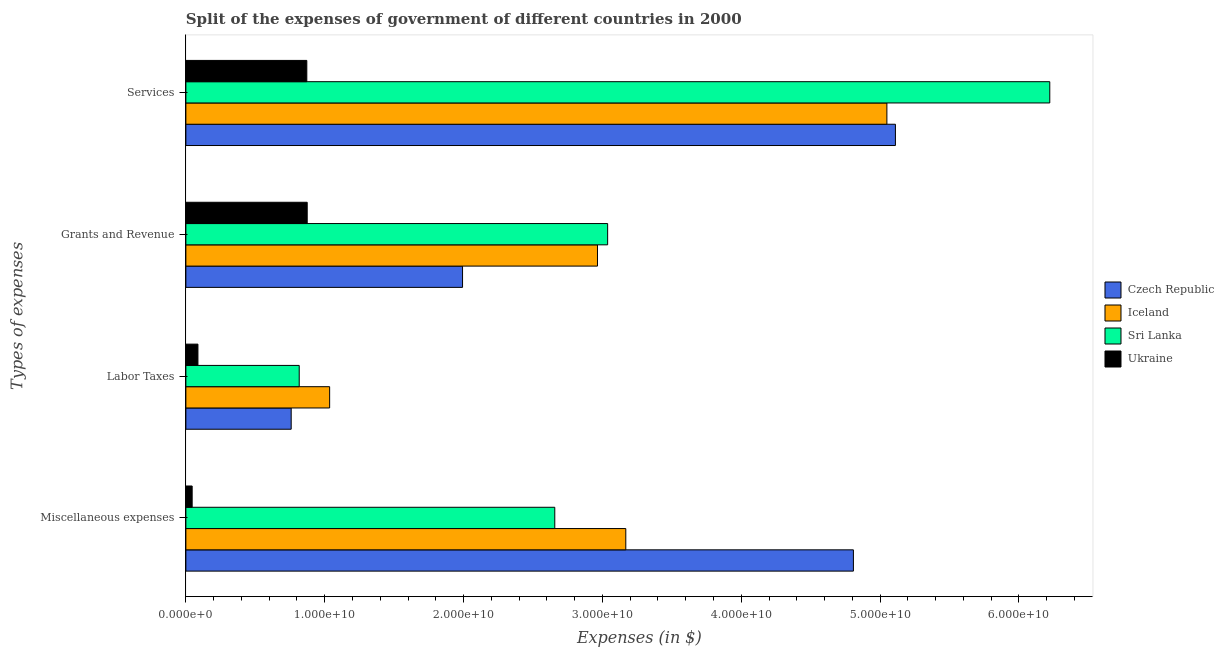How many groups of bars are there?
Provide a short and direct response. 4. Are the number of bars per tick equal to the number of legend labels?
Give a very brief answer. Yes. What is the label of the 2nd group of bars from the top?
Keep it short and to the point. Grants and Revenue. What is the amount spent on labor taxes in Ukraine?
Make the answer very short. 8.69e+08. Across all countries, what is the maximum amount spent on miscellaneous expenses?
Provide a short and direct response. 4.81e+1. Across all countries, what is the minimum amount spent on miscellaneous expenses?
Your response must be concise. 4.53e+08. In which country was the amount spent on miscellaneous expenses maximum?
Keep it short and to the point. Czech Republic. In which country was the amount spent on miscellaneous expenses minimum?
Keep it short and to the point. Ukraine. What is the total amount spent on services in the graph?
Your answer should be compact. 1.73e+11. What is the difference between the amount spent on grants and revenue in Czech Republic and that in Sri Lanka?
Ensure brevity in your answer.  -1.04e+1. What is the difference between the amount spent on miscellaneous expenses in Iceland and the amount spent on grants and revenue in Sri Lanka?
Keep it short and to the point. 1.31e+09. What is the average amount spent on grants and revenue per country?
Your answer should be very brief. 2.22e+1. What is the difference between the amount spent on services and amount spent on labor taxes in Iceland?
Offer a terse response. 4.01e+1. In how many countries, is the amount spent on services greater than 52000000000 $?
Keep it short and to the point. 1. What is the ratio of the amount spent on services in Iceland to that in Sri Lanka?
Offer a terse response. 0.81. Is the difference between the amount spent on labor taxes in Iceland and Czech Republic greater than the difference between the amount spent on services in Iceland and Czech Republic?
Provide a succinct answer. Yes. What is the difference between the highest and the second highest amount spent on labor taxes?
Make the answer very short. 2.19e+09. What is the difference between the highest and the lowest amount spent on services?
Your answer should be very brief. 5.35e+1. In how many countries, is the amount spent on grants and revenue greater than the average amount spent on grants and revenue taken over all countries?
Ensure brevity in your answer.  2. Is it the case that in every country, the sum of the amount spent on miscellaneous expenses and amount spent on grants and revenue is greater than the sum of amount spent on labor taxes and amount spent on services?
Keep it short and to the point. No. What does the 4th bar from the top in Services represents?
Provide a short and direct response. Czech Republic. What does the 1st bar from the bottom in Labor Taxes represents?
Offer a very short reply. Czech Republic. Is it the case that in every country, the sum of the amount spent on miscellaneous expenses and amount spent on labor taxes is greater than the amount spent on grants and revenue?
Make the answer very short. No. How many bars are there?
Give a very brief answer. 16. Are all the bars in the graph horizontal?
Offer a terse response. Yes. What is the difference between two consecutive major ticks on the X-axis?
Your answer should be very brief. 1.00e+1. Are the values on the major ticks of X-axis written in scientific E-notation?
Provide a succinct answer. Yes. Does the graph contain any zero values?
Make the answer very short. No. Does the graph contain grids?
Your answer should be very brief. No. How are the legend labels stacked?
Offer a very short reply. Vertical. What is the title of the graph?
Keep it short and to the point. Split of the expenses of government of different countries in 2000. What is the label or title of the X-axis?
Offer a terse response. Expenses (in $). What is the label or title of the Y-axis?
Ensure brevity in your answer.  Types of expenses. What is the Expenses (in $) in Czech Republic in Miscellaneous expenses?
Your answer should be very brief. 4.81e+1. What is the Expenses (in $) in Iceland in Miscellaneous expenses?
Ensure brevity in your answer.  3.17e+1. What is the Expenses (in $) of Sri Lanka in Miscellaneous expenses?
Provide a short and direct response. 2.66e+1. What is the Expenses (in $) of Ukraine in Miscellaneous expenses?
Provide a short and direct response. 4.53e+08. What is the Expenses (in $) of Czech Republic in Labor Taxes?
Keep it short and to the point. 7.58e+09. What is the Expenses (in $) of Iceland in Labor Taxes?
Give a very brief answer. 1.04e+1. What is the Expenses (in $) of Sri Lanka in Labor Taxes?
Provide a short and direct response. 8.16e+09. What is the Expenses (in $) of Ukraine in Labor Taxes?
Your answer should be compact. 8.69e+08. What is the Expenses (in $) in Czech Republic in Grants and Revenue?
Provide a short and direct response. 1.99e+1. What is the Expenses (in $) in Iceland in Grants and Revenue?
Your answer should be compact. 2.96e+1. What is the Expenses (in $) in Sri Lanka in Grants and Revenue?
Your response must be concise. 3.04e+1. What is the Expenses (in $) of Ukraine in Grants and Revenue?
Provide a short and direct response. 8.74e+09. What is the Expenses (in $) in Czech Republic in Services?
Your answer should be compact. 5.11e+1. What is the Expenses (in $) of Iceland in Services?
Ensure brevity in your answer.  5.05e+1. What is the Expenses (in $) in Sri Lanka in Services?
Give a very brief answer. 6.22e+1. What is the Expenses (in $) in Ukraine in Services?
Your answer should be very brief. 8.71e+09. Across all Types of expenses, what is the maximum Expenses (in $) of Czech Republic?
Offer a terse response. 5.11e+1. Across all Types of expenses, what is the maximum Expenses (in $) in Iceland?
Ensure brevity in your answer.  5.05e+1. Across all Types of expenses, what is the maximum Expenses (in $) in Sri Lanka?
Give a very brief answer. 6.22e+1. Across all Types of expenses, what is the maximum Expenses (in $) of Ukraine?
Make the answer very short. 8.74e+09. Across all Types of expenses, what is the minimum Expenses (in $) in Czech Republic?
Your answer should be compact. 7.58e+09. Across all Types of expenses, what is the minimum Expenses (in $) in Iceland?
Keep it short and to the point. 1.04e+1. Across all Types of expenses, what is the minimum Expenses (in $) in Sri Lanka?
Ensure brevity in your answer.  8.16e+09. Across all Types of expenses, what is the minimum Expenses (in $) of Ukraine?
Offer a terse response. 4.53e+08. What is the total Expenses (in $) in Czech Republic in the graph?
Give a very brief answer. 1.27e+11. What is the total Expenses (in $) in Iceland in the graph?
Give a very brief answer. 1.22e+11. What is the total Expenses (in $) in Sri Lanka in the graph?
Make the answer very short. 1.27e+11. What is the total Expenses (in $) of Ukraine in the graph?
Give a very brief answer. 1.88e+1. What is the difference between the Expenses (in $) in Czech Republic in Miscellaneous expenses and that in Labor Taxes?
Ensure brevity in your answer.  4.05e+1. What is the difference between the Expenses (in $) of Iceland in Miscellaneous expenses and that in Labor Taxes?
Offer a terse response. 2.13e+1. What is the difference between the Expenses (in $) in Sri Lanka in Miscellaneous expenses and that in Labor Taxes?
Provide a short and direct response. 1.84e+1. What is the difference between the Expenses (in $) of Ukraine in Miscellaneous expenses and that in Labor Taxes?
Provide a succinct answer. -4.16e+08. What is the difference between the Expenses (in $) in Czech Republic in Miscellaneous expenses and that in Grants and Revenue?
Offer a terse response. 2.82e+1. What is the difference between the Expenses (in $) of Iceland in Miscellaneous expenses and that in Grants and Revenue?
Your answer should be very brief. 2.04e+09. What is the difference between the Expenses (in $) in Sri Lanka in Miscellaneous expenses and that in Grants and Revenue?
Keep it short and to the point. -3.81e+09. What is the difference between the Expenses (in $) in Ukraine in Miscellaneous expenses and that in Grants and Revenue?
Your response must be concise. -8.29e+09. What is the difference between the Expenses (in $) of Czech Republic in Miscellaneous expenses and that in Services?
Give a very brief answer. -3.03e+09. What is the difference between the Expenses (in $) in Iceland in Miscellaneous expenses and that in Services?
Ensure brevity in your answer.  -1.88e+1. What is the difference between the Expenses (in $) of Sri Lanka in Miscellaneous expenses and that in Services?
Provide a short and direct response. -3.57e+1. What is the difference between the Expenses (in $) of Ukraine in Miscellaneous expenses and that in Services?
Keep it short and to the point. -8.26e+09. What is the difference between the Expenses (in $) in Czech Republic in Labor Taxes and that in Grants and Revenue?
Your response must be concise. -1.23e+1. What is the difference between the Expenses (in $) of Iceland in Labor Taxes and that in Grants and Revenue?
Keep it short and to the point. -1.93e+1. What is the difference between the Expenses (in $) of Sri Lanka in Labor Taxes and that in Grants and Revenue?
Keep it short and to the point. -2.22e+1. What is the difference between the Expenses (in $) of Ukraine in Labor Taxes and that in Grants and Revenue?
Offer a terse response. -7.87e+09. What is the difference between the Expenses (in $) in Czech Republic in Labor Taxes and that in Services?
Make the answer very short. -4.35e+1. What is the difference between the Expenses (in $) of Iceland in Labor Taxes and that in Services?
Provide a succinct answer. -4.01e+1. What is the difference between the Expenses (in $) of Sri Lanka in Labor Taxes and that in Services?
Give a very brief answer. -5.41e+1. What is the difference between the Expenses (in $) of Ukraine in Labor Taxes and that in Services?
Ensure brevity in your answer.  -7.84e+09. What is the difference between the Expenses (in $) in Czech Republic in Grants and Revenue and that in Services?
Your answer should be very brief. -3.12e+1. What is the difference between the Expenses (in $) in Iceland in Grants and Revenue and that in Services?
Your answer should be very brief. -2.08e+1. What is the difference between the Expenses (in $) in Sri Lanka in Grants and Revenue and that in Services?
Your response must be concise. -3.18e+1. What is the difference between the Expenses (in $) in Ukraine in Grants and Revenue and that in Services?
Ensure brevity in your answer.  2.81e+07. What is the difference between the Expenses (in $) of Czech Republic in Miscellaneous expenses and the Expenses (in $) of Iceland in Labor Taxes?
Your response must be concise. 3.77e+1. What is the difference between the Expenses (in $) in Czech Republic in Miscellaneous expenses and the Expenses (in $) in Sri Lanka in Labor Taxes?
Provide a short and direct response. 3.99e+1. What is the difference between the Expenses (in $) in Czech Republic in Miscellaneous expenses and the Expenses (in $) in Ukraine in Labor Taxes?
Make the answer very short. 4.72e+1. What is the difference between the Expenses (in $) of Iceland in Miscellaneous expenses and the Expenses (in $) of Sri Lanka in Labor Taxes?
Ensure brevity in your answer.  2.35e+1. What is the difference between the Expenses (in $) of Iceland in Miscellaneous expenses and the Expenses (in $) of Ukraine in Labor Taxes?
Offer a very short reply. 3.08e+1. What is the difference between the Expenses (in $) in Sri Lanka in Miscellaneous expenses and the Expenses (in $) in Ukraine in Labor Taxes?
Ensure brevity in your answer.  2.57e+1. What is the difference between the Expenses (in $) of Czech Republic in Miscellaneous expenses and the Expenses (in $) of Iceland in Grants and Revenue?
Provide a succinct answer. 1.84e+1. What is the difference between the Expenses (in $) in Czech Republic in Miscellaneous expenses and the Expenses (in $) in Sri Lanka in Grants and Revenue?
Make the answer very short. 1.77e+1. What is the difference between the Expenses (in $) of Czech Republic in Miscellaneous expenses and the Expenses (in $) of Ukraine in Grants and Revenue?
Keep it short and to the point. 3.93e+1. What is the difference between the Expenses (in $) of Iceland in Miscellaneous expenses and the Expenses (in $) of Sri Lanka in Grants and Revenue?
Offer a terse response. 1.31e+09. What is the difference between the Expenses (in $) in Iceland in Miscellaneous expenses and the Expenses (in $) in Ukraine in Grants and Revenue?
Offer a terse response. 2.29e+1. What is the difference between the Expenses (in $) in Sri Lanka in Miscellaneous expenses and the Expenses (in $) in Ukraine in Grants and Revenue?
Provide a succinct answer. 1.78e+1. What is the difference between the Expenses (in $) in Czech Republic in Miscellaneous expenses and the Expenses (in $) in Iceland in Services?
Keep it short and to the point. -2.41e+09. What is the difference between the Expenses (in $) of Czech Republic in Miscellaneous expenses and the Expenses (in $) of Sri Lanka in Services?
Make the answer very short. -1.41e+1. What is the difference between the Expenses (in $) in Czech Republic in Miscellaneous expenses and the Expenses (in $) in Ukraine in Services?
Offer a terse response. 3.94e+1. What is the difference between the Expenses (in $) in Iceland in Miscellaneous expenses and the Expenses (in $) in Sri Lanka in Services?
Offer a very short reply. -3.05e+1. What is the difference between the Expenses (in $) in Iceland in Miscellaneous expenses and the Expenses (in $) in Ukraine in Services?
Offer a very short reply. 2.30e+1. What is the difference between the Expenses (in $) in Sri Lanka in Miscellaneous expenses and the Expenses (in $) in Ukraine in Services?
Make the answer very short. 1.79e+1. What is the difference between the Expenses (in $) of Czech Republic in Labor Taxes and the Expenses (in $) of Iceland in Grants and Revenue?
Provide a short and direct response. -2.21e+1. What is the difference between the Expenses (in $) of Czech Republic in Labor Taxes and the Expenses (in $) of Sri Lanka in Grants and Revenue?
Ensure brevity in your answer.  -2.28e+1. What is the difference between the Expenses (in $) of Czech Republic in Labor Taxes and the Expenses (in $) of Ukraine in Grants and Revenue?
Make the answer very short. -1.15e+09. What is the difference between the Expenses (in $) in Iceland in Labor Taxes and the Expenses (in $) in Sri Lanka in Grants and Revenue?
Offer a very short reply. -2.00e+1. What is the difference between the Expenses (in $) of Iceland in Labor Taxes and the Expenses (in $) of Ukraine in Grants and Revenue?
Offer a terse response. 1.62e+09. What is the difference between the Expenses (in $) in Sri Lanka in Labor Taxes and the Expenses (in $) in Ukraine in Grants and Revenue?
Keep it short and to the point. -5.75e+08. What is the difference between the Expenses (in $) of Czech Republic in Labor Taxes and the Expenses (in $) of Iceland in Services?
Offer a terse response. -4.29e+1. What is the difference between the Expenses (in $) of Czech Republic in Labor Taxes and the Expenses (in $) of Sri Lanka in Services?
Offer a terse response. -5.46e+1. What is the difference between the Expenses (in $) of Czech Republic in Labor Taxes and the Expenses (in $) of Ukraine in Services?
Make the answer very short. -1.13e+09. What is the difference between the Expenses (in $) of Iceland in Labor Taxes and the Expenses (in $) of Sri Lanka in Services?
Keep it short and to the point. -5.19e+1. What is the difference between the Expenses (in $) of Iceland in Labor Taxes and the Expenses (in $) of Ukraine in Services?
Keep it short and to the point. 1.64e+09. What is the difference between the Expenses (in $) in Sri Lanka in Labor Taxes and the Expenses (in $) in Ukraine in Services?
Provide a succinct answer. -5.47e+08. What is the difference between the Expenses (in $) of Czech Republic in Grants and Revenue and the Expenses (in $) of Iceland in Services?
Your answer should be compact. -3.06e+1. What is the difference between the Expenses (in $) of Czech Republic in Grants and Revenue and the Expenses (in $) of Sri Lanka in Services?
Your response must be concise. -4.23e+1. What is the difference between the Expenses (in $) of Czech Republic in Grants and Revenue and the Expenses (in $) of Ukraine in Services?
Give a very brief answer. 1.12e+1. What is the difference between the Expenses (in $) of Iceland in Grants and Revenue and the Expenses (in $) of Sri Lanka in Services?
Provide a short and direct response. -3.26e+1. What is the difference between the Expenses (in $) in Iceland in Grants and Revenue and the Expenses (in $) in Ukraine in Services?
Offer a very short reply. 2.09e+1. What is the difference between the Expenses (in $) in Sri Lanka in Grants and Revenue and the Expenses (in $) in Ukraine in Services?
Ensure brevity in your answer.  2.17e+1. What is the average Expenses (in $) in Czech Republic per Types of expenses?
Make the answer very short. 3.17e+1. What is the average Expenses (in $) of Iceland per Types of expenses?
Your response must be concise. 3.05e+1. What is the average Expenses (in $) in Sri Lanka per Types of expenses?
Make the answer very short. 3.18e+1. What is the average Expenses (in $) of Ukraine per Types of expenses?
Offer a very short reply. 4.69e+09. What is the difference between the Expenses (in $) of Czech Republic and Expenses (in $) of Iceland in Miscellaneous expenses?
Make the answer very short. 1.64e+1. What is the difference between the Expenses (in $) in Czech Republic and Expenses (in $) in Sri Lanka in Miscellaneous expenses?
Offer a terse response. 2.15e+1. What is the difference between the Expenses (in $) in Czech Republic and Expenses (in $) in Ukraine in Miscellaneous expenses?
Your answer should be very brief. 4.76e+1. What is the difference between the Expenses (in $) in Iceland and Expenses (in $) in Sri Lanka in Miscellaneous expenses?
Provide a short and direct response. 5.11e+09. What is the difference between the Expenses (in $) in Iceland and Expenses (in $) in Ukraine in Miscellaneous expenses?
Provide a succinct answer. 3.12e+1. What is the difference between the Expenses (in $) of Sri Lanka and Expenses (in $) of Ukraine in Miscellaneous expenses?
Ensure brevity in your answer.  2.61e+1. What is the difference between the Expenses (in $) in Czech Republic and Expenses (in $) in Iceland in Labor Taxes?
Your answer should be compact. -2.77e+09. What is the difference between the Expenses (in $) of Czech Republic and Expenses (in $) of Sri Lanka in Labor Taxes?
Ensure brevity in your answer.  -5.78e+08. What is the difference between the Expenses (in $) in Czech Republic and Expenses (in $) in Ukraine in Labor Taxes?
Offer a terse response. 6.72e+09. What is the difference between the Expenses (in $) in Iceland and Expenses (in $) in Sri Lanka in Labor Taxes?
Ensure brevity in your answer.  2.19e+09. What is the difference between the Expenses (in $) of Iceland and Expenses (in $) of Ukraine in Labor Taxes?
Your answer should be compact. 9.48e+09. What is the difference between the Expenses (in $) in Sri Lanka and Expenses (in $) in Ukraine in Labor Taxes?
Offer a terse response. 7.29e+09. What is the difference between the Expenses (in $) in Czech Republic and Expenses (in $) in Iceland in Grants and Revenue?
Give a very brief answer. -9.72e+09. What is the difference between the Expenses (in $) in Czech Republic and Expenses (in $) in Sri Lanka in Grants and Revenue?
Make the answer very short. -1.04e+1. What is the difference between the Expenses (in $) in Czech Republic and Expenses (in $) in Ukraine in Grants and Revenue?
Provide a succinct answer. 1.12e+1. What is the difference between the Expenses (in $) of Iceland and Expenses (in $) of Sri Lanka in Grants and Revenue?
Offer a very short reply. -7.32e+08. What is the difference between the Expenses (in $) of Iceland and Expenses (in $) of Ukraine in Grants and Revenue?
Provide a succinct answer. 2.09e+1. What is the difference between the Expenses (in $) in Sri Lanka and Expenses (in $) in Ukraine in Grants and Revenue?
Make the answer very short. 2.16e+1. What is the difference between the Expenses (in $) of Czech Republic and Expenses (in $) of Iceland in Services?
Make the answer very short. 6.15e+08. What is the difference between the Expenses (in $) in Czech Republic and Expenses (in $) in Sri Lanka in Services?
Your answer should be very brief. -1.11e+1. What is the difference between the Expenses (in $) in Czech Republic and Expenses (in $) in Ukraine in Services?
Make the answer very short. 4.24e+1. What is the difference between the Expenses (in $) of Iceland and Expenses (in $) of Sri Lanka in Services?
Give a very brief answer. -1.17e+1. What is the difference between the Expenses (in $) in Iceland and Expenses (in $) in Ukraine in Services?
Give a very brief answer. 4.18e+1. What is the difference between the Expenses (in $) in Sri Lanka and Expenses (in $) in Ukraine in Services?
Your answer should be very brief. 5.35e+1. What is the ratio of the Expenses (in $) in Czech Republic in Miscellaneous expenses to that in Labor Taxes?
Offer a very short reply. 6.34. What is the ratio of the Expenses (in $) in Iceland in Miscellaneous expenses to that in Labor Taxes?
Provide a short and direct response. 3.06. What is the ratio of the Expenses (in $) in Sri Lanka in Miscellaneous expenses to that in Labor Taxes?
Ensure brevity in your answer.  3.25. What is the ratio of the Expenses (in $) of Ukraine in Miscellaneous expenses to that in Labor Taxes?
Make the answer very short. 0.52. What is the ratio of the Expenses (in $) in Czech Republic in Miscellaneous expenses to that in Grants and Revenue?
Your answer should be very brief. 2.41. What is the ratio of the Expenses (in $) of Iceland in Miscellaneous expenses to that in Grants and Revenue?
Give a very brief answer. 1.07. What is the ratio of the Expenses (in $) in Sri Lanka in Miscellaneous expenses to that in Grants and Revenue?
Offer a terse response. 0.87. What is the ratio of the Expenses (in $) of Ukraine in Miscellaneous expenses to that in Grants and Revenue?
Provide a succinct answer. 0.05. What is the ratio of the Expenses (in $) in Czech Republic in Miscellaneous expenses to that in Services?
Make the answer very short. 0.94. What is the ratio of the Expenses (in $) of Iceland in Miscellaneous expenses to that in Services?
Make the answer very short. 0.63. What is the ratio of the Expenses (in $) of Sri Lanka in Miscellaneous expenses to that in Services?
Provide a succinct answer. 0.43. What is the ratio of the Expenses (in $) in Ukraine in Miscellaneous expenses to that in Services?
Your answer should be very brief. 0.05. What is the ratio of the Expenses (in $) of Czech Republic in Labor Taxes to that in Grants and Revenue?
Offer a very short reply. 0.38. What is the ratio of the Expenses (in $) of Iceland in Labor Taxes to that in Grants and Revenue?
Your answer should be very brief. 0.35. What is the ratio of the Expenses (in $) in Sri Lanka in Labor Taxes to that in Grants and Revenue?
Your answer should be compact. 0.27. What is the ratio of the Expenses (in $) in Ukraine in Labor Taxes to that in Grants and Revenue?
Your answer should be compact. 0.1. What is the ratio of the Expenses (in $) in Czech Republic in Labor Taxes to that in Services?
Make the answer very short. 0.15. What is the ratio of the Expenses (in $) in Iceland in Labor Taxes to that in Services?
Give a very brief answer. 0.21. What is the ratio of the Expenses (in $) in Sri Lanka in Labor Taxes to that in Services?
Provide a succinct answer. 0.13. What is the ratio of the Expenses (in $) in Ukraine in Labor Taxes to that in Services?
Ensure brevity in your answer.  0.1. What is the ratio of the Expenses (in $) in Czech Republic in Grants and Revenue to that in Services?
Give a very brief answer. 0.39. What is the ratio of the Expenses (in $) of Iceland in Grants and Revenue to that in Services?
Offer a terse response. 0.59. What is the ratio of the Expenses (in $) in Sri Lanka in Grants and Revenue to that in Services?
Your answer should be very brief. 0.49. What is the difference between the highest and the second highest Expenses (in $) in Czech Republic?
Your answer should be compact. 3.03e+09. What is the difference between the highest and the second highest Expenses (in $) of Iceland?
Your response must be concise. 1.88e+1. What is the difference between the highest and the second highest Expenses (in $) of Sri Lanka?
Provide a succinct answer. 3.18e+1. What is the difference between the highest and the second highest Expenses (in $) in Ukraine?
Give a very brief answer. 2.81e+07. What is the difference between the highest and the lowest Expenses (in $) of Czech Republic?
Offer a very short reply. 4.35e+1. What is the difference between the highest and the lowest Expenses (in $) of Iceland?
Ensure brevity in your answer.  4.01e+1. What is the difference between the highest and the lowest Expenses (in $) of Sri Lanka?
Your answer should be very brief. 5.41e+1. What is the difference between the highest and the lowest Expenses (in $) in Ukraine?
Provide a succinct answer. 8.29e+09. 